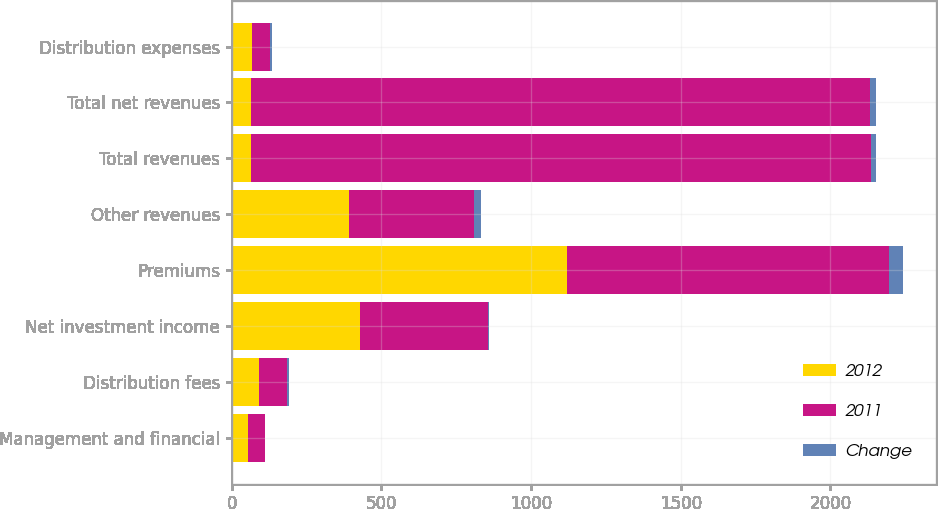Convert chart to OTSL. <chart><loc_0><loc_0><loc_500><loc_500><stacked_bar_chart><ecel><fcel>Management and financial<fcel>Distribution fees<fcel>Net investment income<fcel>Premiums<fcel>Other revenues<fcel>Total revenues<fcel>Total net revenues<fcel>Distribution expenses<nl><fcel>2012<fcel>55<fcel>91<fcel>430<fcel>1121<fcel>392<fcel>64.5<fcel>64.5<fcel>67<nl><fcel>2011<fcel>56<fcel>95<fcel>426<fcel>1076<fcel>417<fcel>2070<fcel>2069<fcel>62<nl><fcel>Change<fcel>1<fcel>4<fcel>4<fcel>45<fcel>25<fcel>19<fcel>19<fcel>5<nl></chart> 